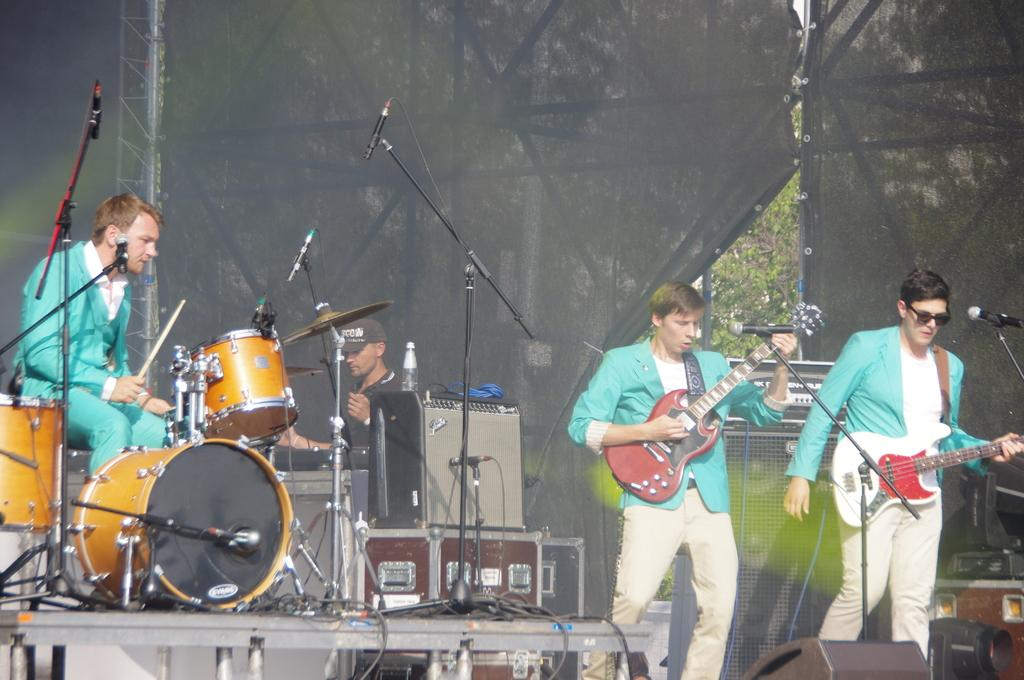What is the man in the image doing? The man is playing drums. How many people are in the image? There are two men in the image. What are the other man and the drummer holding? Each of the two men is holding a guitar. What type of paste is being used by the man playing drums in the image? There is no paste present in the image; the man is playing drums and the other man is holding a guitar. 